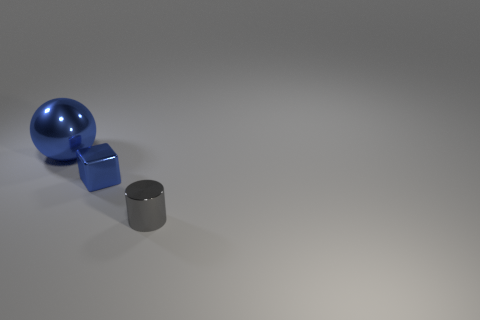Subtract all green cubes. Subtract all cyan balls. How many cubes are left? 1 Add 2 metal cylinders. How many objects exist? 5 Subtract all blocks. How many objects are left? 2 Subtract all big metallic balls. Subtract all large cyan shiny cylinders. How many objects are left? 2 Add 2 large metallic things. How many large metallic things are left? 3 Add 1 tiny blue metal objects. How many tiny blue metal objects exist? 2 Subtract 0 gray cubes. How many objects are left? 3 